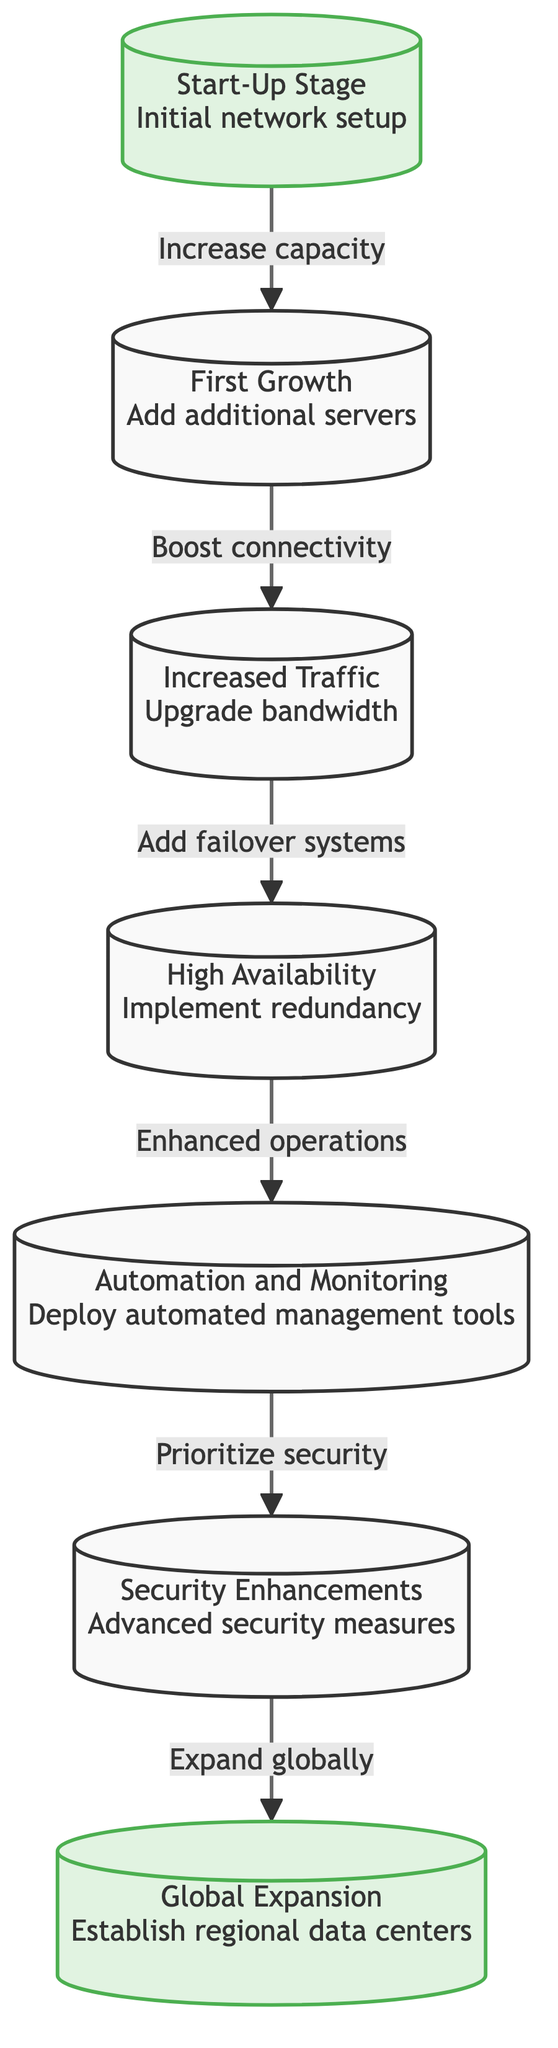What is the first milestone in the roadmap? The first milestone mentioned in the diagram is the "Start-Up Stage" where there is an "Initial network setup". It is the first node in the sequence of the roadmap.
Answer: Start-Up Stage How many total nodes are depicted in the diagram? The diagram contains seven nodes including the milestone nodes and the subsequent growth stages. Each node represents a key milestone in the scaling roadmap.
Answer: 7 What key step follows after "Increased Traffic"? After the "Increased Traffic" node, the next step in the roadmap is "High Availability" where "Implement redundancy" occurs. This indicates a focus on ensuring network reliability.
Answer: High Availability What milestone occurs last in the roadmap? The last milestone in the roadmap is "Global Expansion," which involves establishing regional data centers as part of the scaling process. It serves as the endpoint of the diagram.
Answer: Global Expansion What is the relationship between "First Growth" and "Increased Traffic"? The relationship depicted is that "First Growth" leads to "Increased Traffic" through the connection labeled "Boost connectivity," indicating an enhancement in server capabilities.
Answer: Boost connectivity Which step is focused on security after implementing redundancy? The step that follows the implementation of redundancy and is focused on security is "Security Enhancements" where advanced measures are deployed to better protect the network.
Answer: Security Enhancements How does the roadmap progress from "Automation and Monitoring"? The progress from "Automation and Monitoring" leads to "Security Enhancements". The transition in the diagram shows a focus on prioritizing security after deploying automated management tools.
Answer: Security Enhancements What action is associated with the node labeled "High Availability"? The action associated with "High Availability" is to "Implement redundancy," which is crucial for ensuring that the network remains operational in case of failures.
Answer: Implement redundancy 